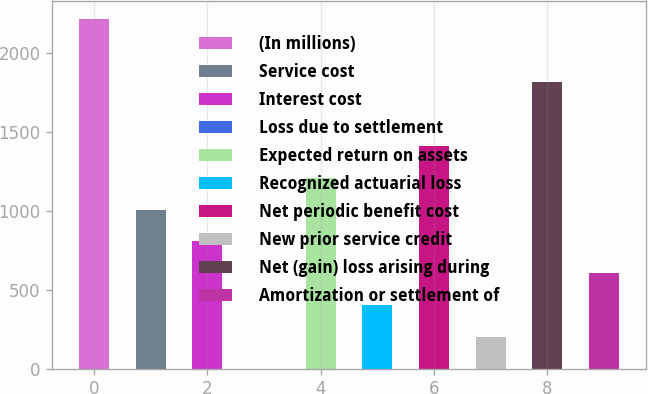Convert chart to OTSL. <chart><loc_0><loc_0><loc_500><loc_500><bar_chart><fcel>(In millions)<fcel>Service cost<fcel>Interest cost<fcel>Loss due to settlement<fcel>Expected return on assets<fcel>Recognized actuarial loss<fcel>Net periodic benefit cost<fcel>New prior service credit<fcel>Net (gain) loss arising during<fcel>Amortization or settlement of<nl><fcel>2217.5<fcel>1008.5<fcel>807<fcel>1<fcel>1210<fcel>404<fcel>1411.5<fcel>202.5<fcel>1814.5<fcel>605.5<nl></chart> 